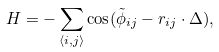<formula> <loc_0><loc_0><loc_500><loc_500>H = - \sum _ { \langle i , j \rangle } \cos ( \tilde { \phi } _ { i j } - { r } _ { i j } \cdot \Delta ) ,</formula> 